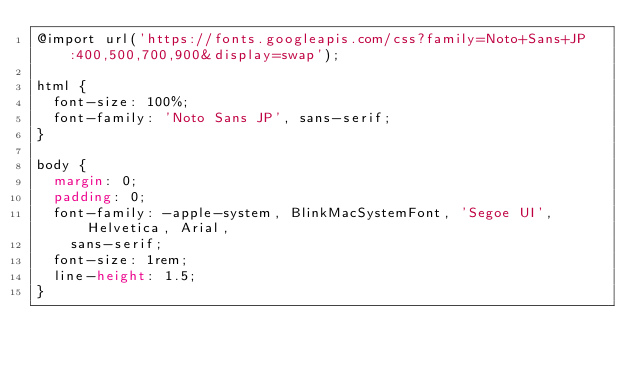Convert code to text. <code><loc_0><loc_0><loc_500><loc_500><_CSS_>@import url('https://fonts.googleapis.com/css?family=Noto+Sans+JP:400,500,700,900&display=swap');

html {
  font-size: 100%;
  font-family: 'Noto Sans JP', sans-serif;
}

body {
  margin: 0;
  padding: 0;
  font-family: -apple-system, BlinkMacSystemFont, 'Segoe UI', Helvetica, Arial,
    sans-serif;
  font-size: 1rem;
  line-height: 1.5;
}</code> 